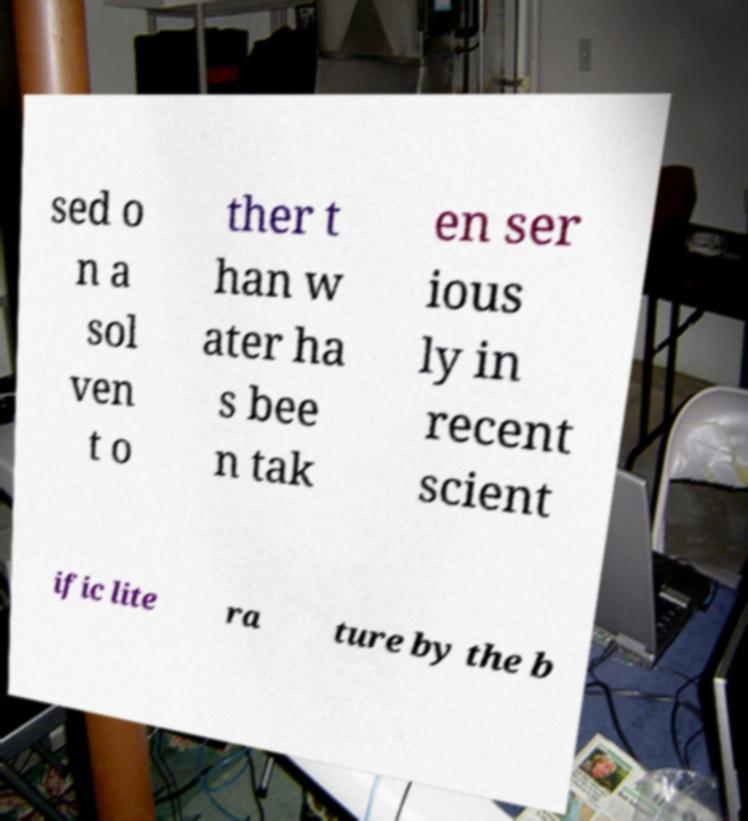There's text embedded in this image that I need extracted. Can you transcribe it verbatim? sed o n a sol ven t o ther t han w ater ha s bee n tak en ser ious ly in recent scient ific lite ra ture by the b 